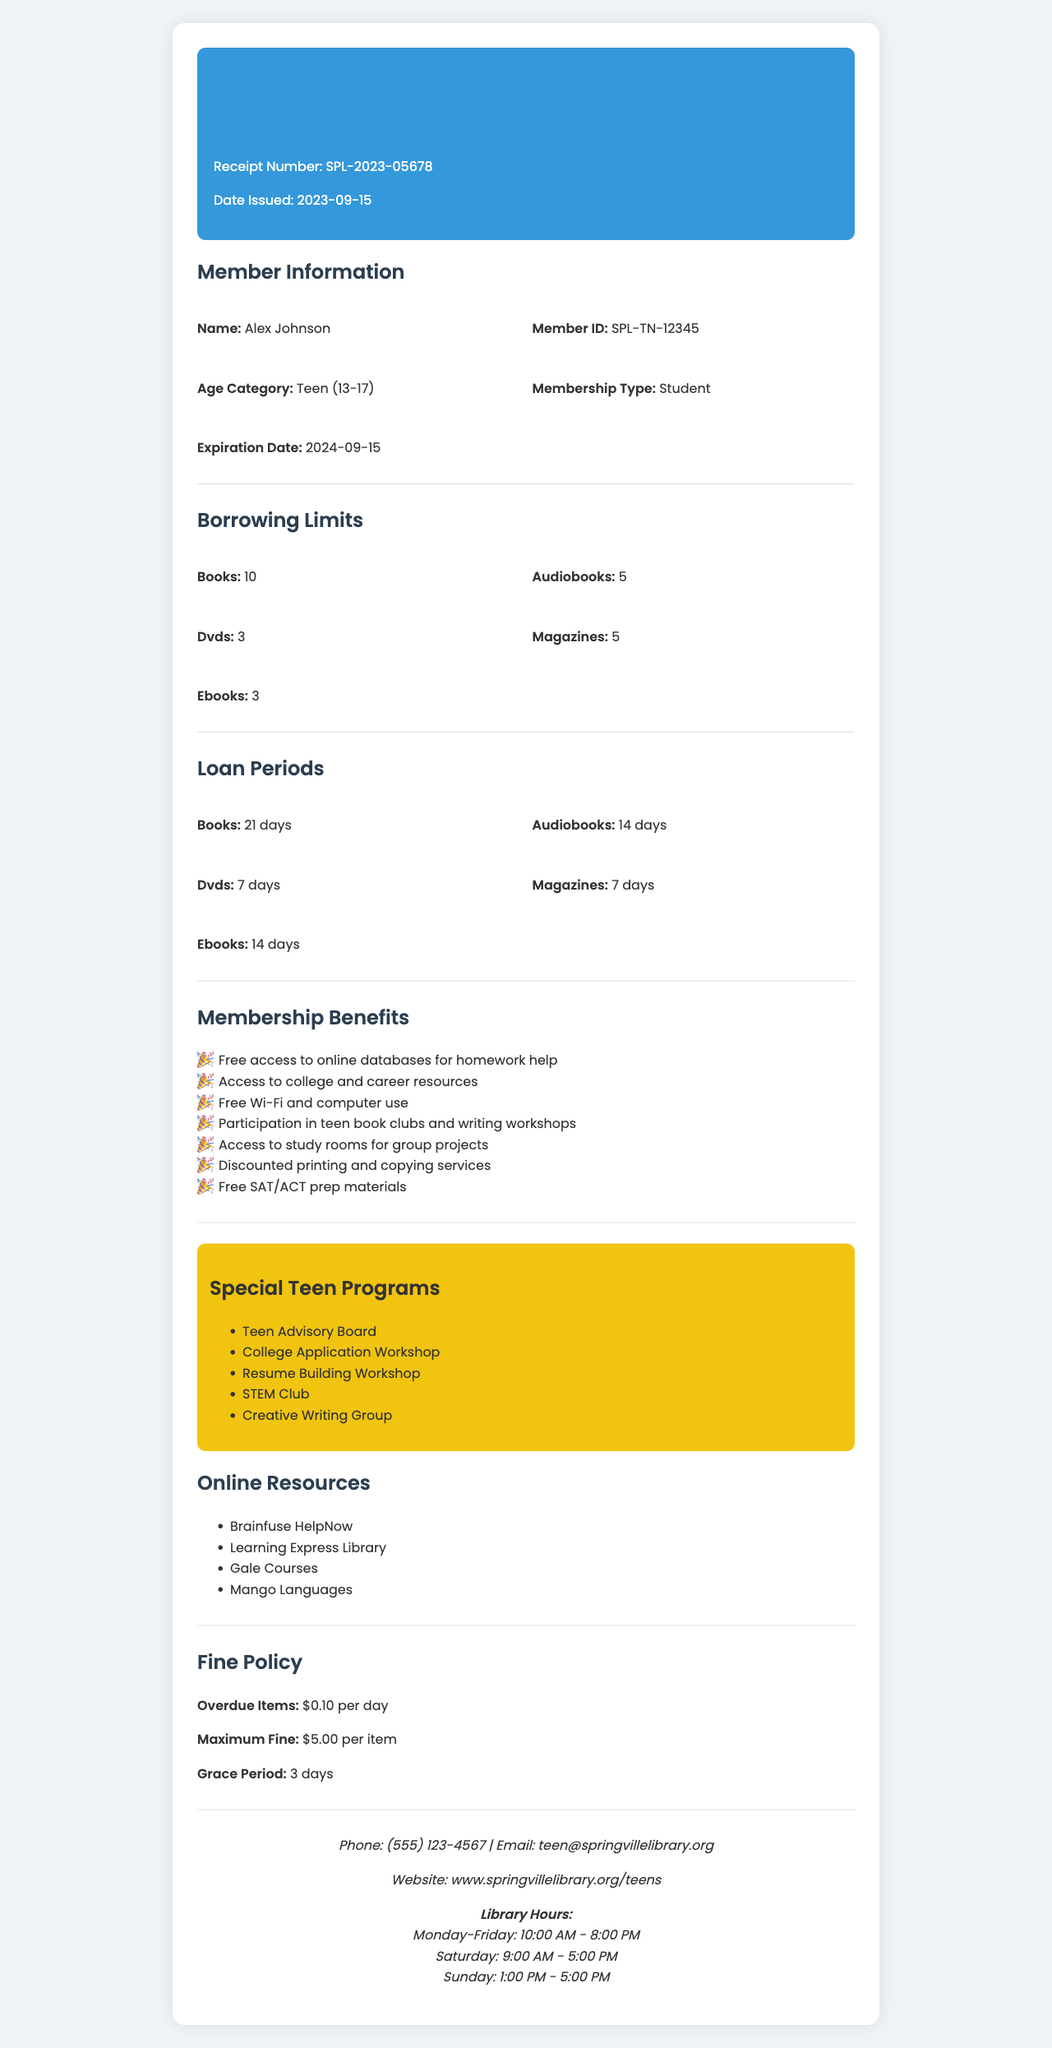What is the name of the library? The library's name is listed at the top of the document.
Answer: Springville Public Library What is the member ID? The member ID is provided in the member information section of the document.
Answer: SPL-TN-12345 How long is the borrowing period for books? The loan period for books is specified in the loan periods section.
Answer: 21 days What is the maximum fine for overdue items? The maximum fine for overdue items is mentioned in the fine policy section.
Answer: $5.00 per item What age category does the member belong to? The age category is shown in the member information section.
Answer: Teen (13-17) How many special teen programs are listed? The number of special teen programs can be counted in the respective section.
Answer: 5 What benefit includes access to college resources? Membership benefits related to college resources are specifically mentioned.
Answer: Access to college and career resources When does the membership expire? The expiration date of the membership is stated in the member information section.
Answer: 2024-09-15 What are the library hours on Saturday? The library hours for Saturday are listed under the contact information section.
Answer: 9:00 AM - 5:00 PM 